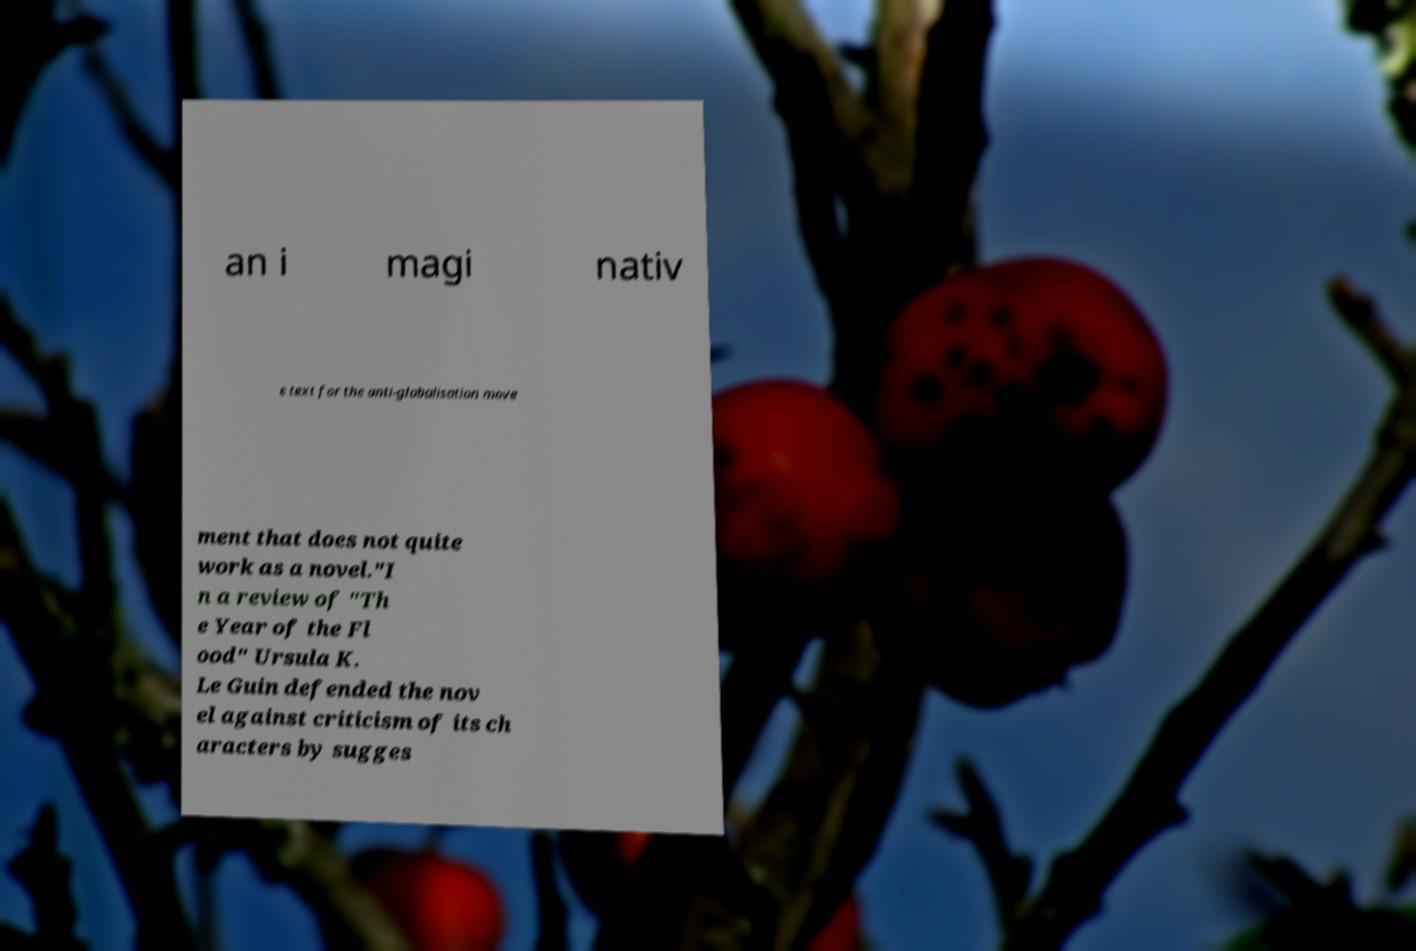For documentation purposes, I need the text within this image transcribed. Could you provide that? an i magi nativ e text for the anti-globalisation move ment that does not quite work as a novel."I n a review of "Th e Year of the Fl ood" Ursula K. Le Guin defended the nov el against criticism of its ch aracters by sugges 